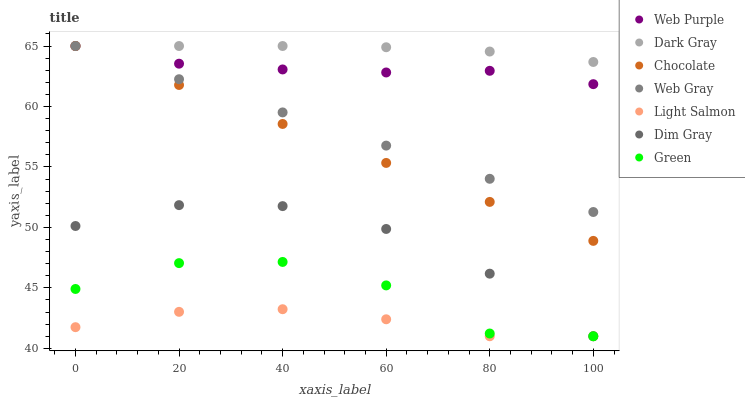Does Light Salmon have the minimum area under the curve?
Answer yes or no. Yes. Does Dark Gray have the maximum area under the curve?
Answer yes or no. Yes. Does Web Gray have the minimum area under the curve?
Answer yes or no. No. Does Web Gray have the maximum area under the curve?
Answer yes or no. No. Is Web Gray the smoothest?
Answer yes or no. Yes. Is Green the roughest?
Answer yes or no. Yes. Is Dark Gray the smoothest?
Answer yes or no. No. Is Dark Gray the roughest?
Answer yes or no. No. Does Light Salmon have the lowest value?
Answer yes or no. Yes. Does Web Gray have the lowest value?
Answer yes or no. No. Does Web Purple have the highest value?
Answer yes or no. Yes. Does Dim Gray have the highest value?
Answer yes or no. No. Is Green less than Chocolate?
Answer yes or no. Yes. Is Chocolate greater than Dim Gray?
Answer yes or no. Yes. Does Green intersect Dim Gray?
Answer yes or no. Yes. Is Green less than Dim Gray?
Answer yes or no. No. Is Green greater than Dim Gray?
Answer yes or no. No. Does Green intersect Chocolate?
Answer yes or no. No. 